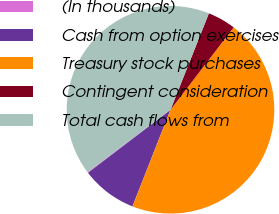Convert chart. <chart><loc_0><loc_0><loc_500><loc_500><pie_chart><fcel>(In thousands)<fcel>Cash from option exercises<fcel>Treasury stock purchases<fcel>Contingent consideration<fcel>Total cash flows from<nl><fcel>0.12%<fcel>8.65%<fcel>45.55%<fcel>4.38%<fcel>41.29%<nl></chart> 